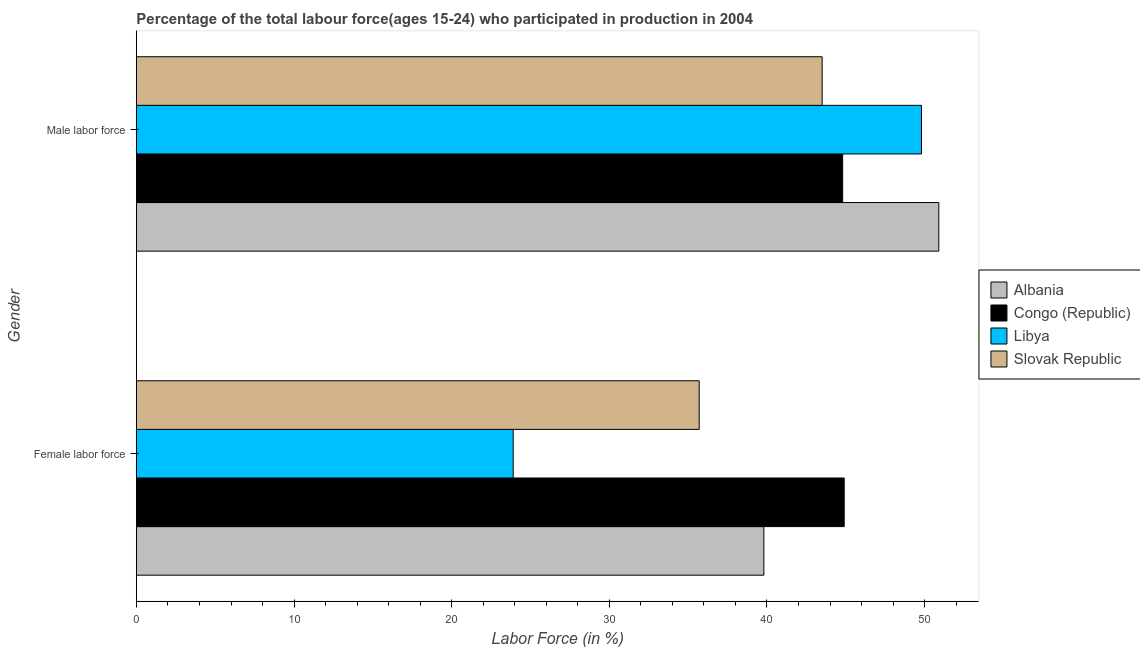How many different coloured bars are there?
Your response must be concise. 4. How many groups of bars are there?
Keep it short and to the point. 2. Are the number of bars per tick equal to the number of legend labels?
Provide a succinct answer. Yes. How many bars are there on the 1st tick from the top?
Offer a very short reply. 4. How many bars are there on the 1st tick from the bottom?
Make the answer very short. 4. What is the label of the 2nd group of bars from the top?
Your response must be concise. Female labor force. What is the percentage of female labor force in Albania?
Make the answer very short. 39.8. Across all countries, what is the maximum percentage of female labor force?
Make the answer very short. 44.9. Across all countries, what is the minimum percentage of female labor force?
Your answer should be very brief. 23.9. In which country was the percentage of male labour force maximum?
Provide a short and direct response. Albania. In which country was the percentage of female labor force minimum?
Your answer should be compact. Libya. What is the total percentage of female labor force in the graph?
Your response must be concise. 144.3. What is the difference between the percentage of male labour force in Slovak Republic and that in Congo (Republic)?
Keep it short and to the point. -1.3. What is the difference between the percentage of female labor force in Slovak Republic and the percentage of male labour force in Libya?
Make the answer very short. -14.1. What is the average percentage of female labor force per country?
Your answer should be compact. 36.08. What is the difference between the percentage of female labor force and percentage of male labour force in Libya?
Offer a very short reply. -25.9. In how many countries, is the percentage of female labor force greater than 42 %?
Your answer should be very brief. 1. What is the ratio of the percentage of male labour force in Albania to that in Slovak Republic?
Your answer should be compact. 1.17. Is the percentage of male labour force in Slovak Republic less than that in Albania?
Offer a terse response. Yes. What does the 4th bar from the top in Male labor force represents?
Provide a succinct answer. Albania. What does the 2nd bar from the bottom in Male labor force represents?
Your answer should be compact. Congo (Republic). Are all the bars in the graph horizontal?
Provide a short and direct response. Yes. How many countries are there in the graph?
Ensure brevity in your answer.  4. What is the difference between two consecutive major ticks on the X-axis?
Ensure brevity in your answer.  10. Are the values on the major ticks of X-axis written in scientific E-notation?
Your answer should be compact. No. Does the graph contain any zero values?
Ensure brevity in your answer.  No. How many legend labels are there?
Your answer should be very brief. 4. How are the legend labels stacked?
Your answer should be very brief. Vertical. What is the title of the graph?
Provide a short and direct response. Percentage of the total labour force(ages 15-24) who participated in production in 2004. Does "Timor-Leste" appear as one of the legend labels in the graph?
Offer a very short reply. No. What is the Labor Force (in %) of Albania in Female labor force?
Provide a short and direct response. 39.8. What is the Labor Force (in %) in Congo (Republic) in Female labor force?
Your answer should be compact. 44.9. What is the Labor Force (in %) of Libya in Female labor force?
Ensure brevity in your answer.  23.9. What is the Labor Force (in %) of Slovak Republic in Female labor force?
Keep it short and to the point. 35.7. What is the Labor Force (in %) in Albania in Male labor force?
Give a very brief answer. 50.9. What is the Labor Force (in %) in Congo (Republic) in Male labor force?
Offer a very short reply. 44.8. What is the Labor Force (in %) in Libya in Male labor force?
Your response must be concise. 49.8. What is the Labor Force (in %) in Slovak Republic in Male labor force?
Offer a very short reply. 43.5. Across all Gender, what is the maximum Labor Force (in %) of Albania?
Give a very brief answer. 50.9. Across all Gender, what is the maximum Labor Force (in %) of Congo (Republic)?
Your answer should be compact. 44.9. Across all Gender, what is the maximum Labor Force (in %) of Libya?
Your response must be concise. 49.8. Across all Gender, what is the maximum Labor Force (in %) of Slovak Republic?
Ensure brevity in your answer.  43.5. Across all Gender, what is the minimum Labor Force (in %) of Albania?
Give a very brief answer. 39.8. Across all Gender, what is the minimum Labor Force (in %) of Congo (Republic)?
Your answer should be compact. 44.8. Across all Gender, what is the minimum Labor Force (in %) in Libya?
Offer a terse response. 23.9. Across all Gender, what is the minimum Labor Force (in %) of Slovak Republic?
Provide a succinct answer. 35.7. What is the total Labor Force (in %) in Albania in the graph?
Your response must be concise. 90.7. What is the total Labor Force (in %) in Congo (Republic) in the graph?
Your response must be concise. 89.7. What is the total Labor Force (in %) in Libya in the graph?
Offer a terse response. 73.7. What is the total Labor Force (in %) of Slovak Republic in the graph?
Your response must be concise. 79.2. What is the difference between the Labor Force (in %) of Albania in Female labor force and that in Male labor force?
Your answer should be very brief. -11.1. What is the difference between the Labor Force (in %) in Congo (Republic) in Female labor force and that in Male labor force?
Your answer should be very brief. 0.1. What is the difference between the Labor Force (in %) of Libya in Female labor force and that in Male labor force?
Offer a very short reply. -25.9. What is the difference between the Labor Force (in %) in Slovak Republic in Female labor force and that in Male labor force?
Make the answer very short. -7.8. What is the difference between the Labor Force (in %) of Albania in Female labor force and the Labor Force (in %) of Libya in Male labor force?
Make the answer very short. -10. What is the difference between the Labor Force (in %) of Albania in Female labor force and the Labor Force (in %) of Slovak Republic in Male labor force?
Provide a succinct answer. -3.7. What is the difference between the Labor Force (in %) of Congo (Republic) in Female labor force and the Labor Force (in %) of Libya in Male labor force?
Provide a succinct answer. -4.9. What is the difference between the Labor Force (in %) in Libya in Female labor force and the Labor Force (in %) in Slovak Republic in Male labor force?
Your answer should be compact. -19.6. What is the average Labor Force (in %) of Albania per Gender?
Offer a very short reply. 45.35. What is the average Labor Force (in %) in Congo (Republic) per Gender?
Ensure brevity in your answer.  44.85. What is the average Labor Force (in %) in Libya per Gender?
Give a very brief answer. 36.85. What is the average Labor Force (in %) of Slovak Republic per Gender?
Your response must be concise. 39.6. What is the difference between the Labor Force (in %) in Albania and Labor Force (in %) in Congo (Republic) in Male labor force?
Give a very brief answer. 6.1. What is the ratio of the Labor Force (in %) in Albania in Female labor force to that in Male labor force?
Offer a terse response. 0.78. What is the ratio of the Labor Force (in %) of Congo (Republic) in Female labor force to that in Male labor force?
Keep it short and to the point. 1. What is the ratio of the Labor Force (in %) in Libya in Female labor force to that in Male labor force?
Offer a terse response. 0.48. What is the ratio of the Labor Force (in %) in Slovak Republic in Female labor force to that in Male labor force?
Keep it short and to the point. 0.82. What is the difference between the highest and the second highest Labor Force (in %) in Albania?
Provide a succinct answer. 11.1. What is the difference between the highest and the second highest Labor Force (in %) of Libya?
Give a very brief answer. 25.9. What is the difference between the highest and the lowest Labor Force (in %) in Albania?
Provide a succinct answer. 11.1. What is the difference between the highest and the lowest Labor Force (in %) in Congo (Republic)?
Ensure brevity in your answer.  0.1. What is the difference between the highest and the lowest Labor Force (in %) of Libya?
Give a very brief answer. 25.9. 